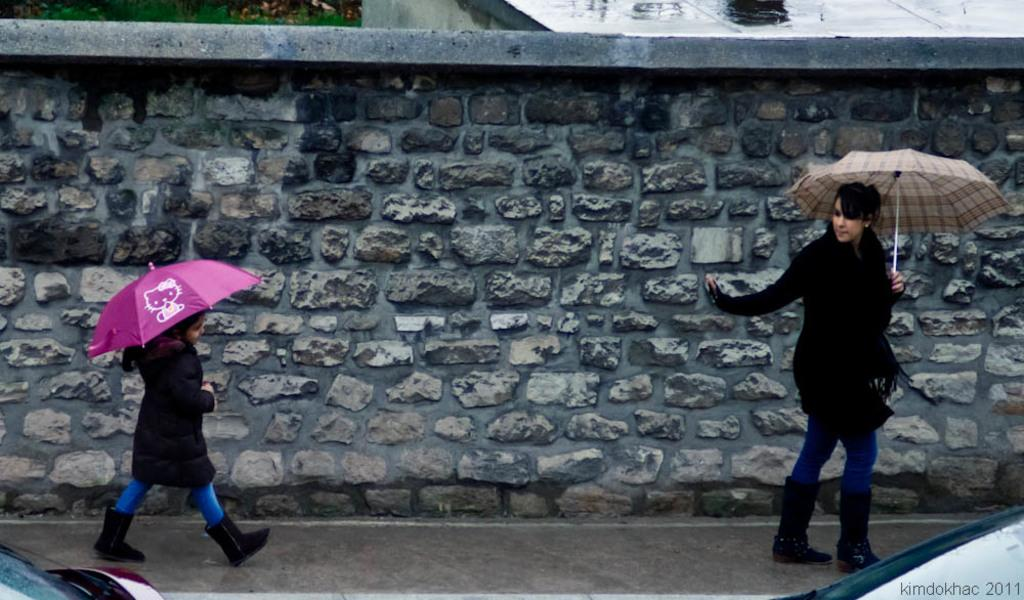How many people are in the image? There are two persons in the image. What are the persons holding in the image? The persons are holding umbrellas. What else can be seen in the image besides the people? There are vehicles visible in the image. What is in the background of the image? There is a wall in the background of the image. What type of rhythm is the grandmother playing on the piano in the image? There is no grandmother or piano present in the image. 